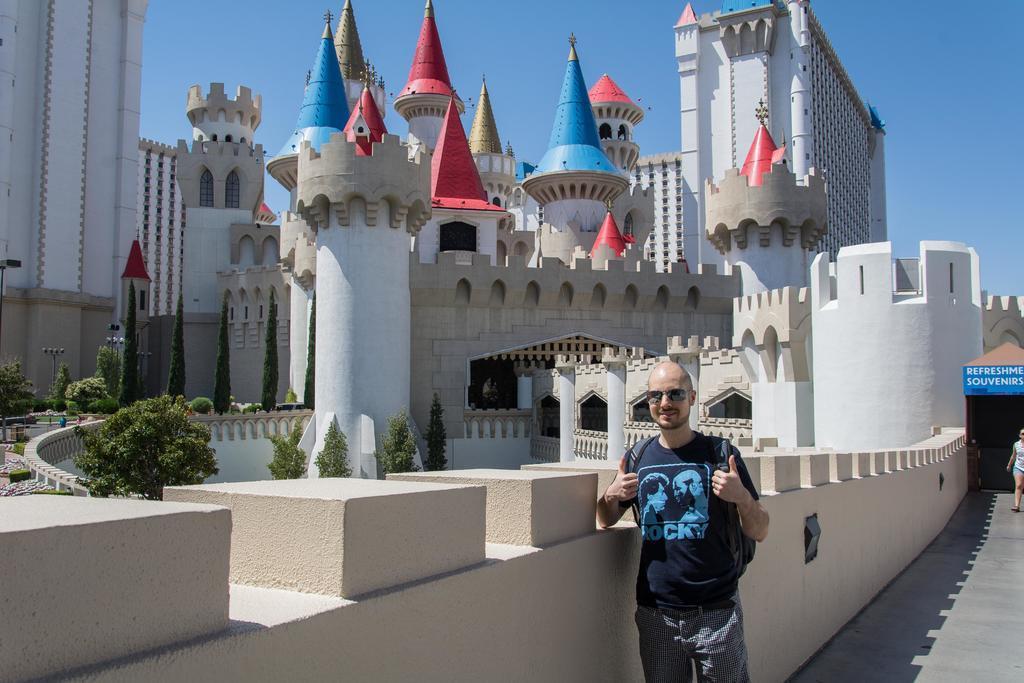Describe this image in one or two sentences. In the center of the image there is a person standing on the floor. On the right side of the image we can see a woman on the road. In the background we can see castle, trees and sky. 